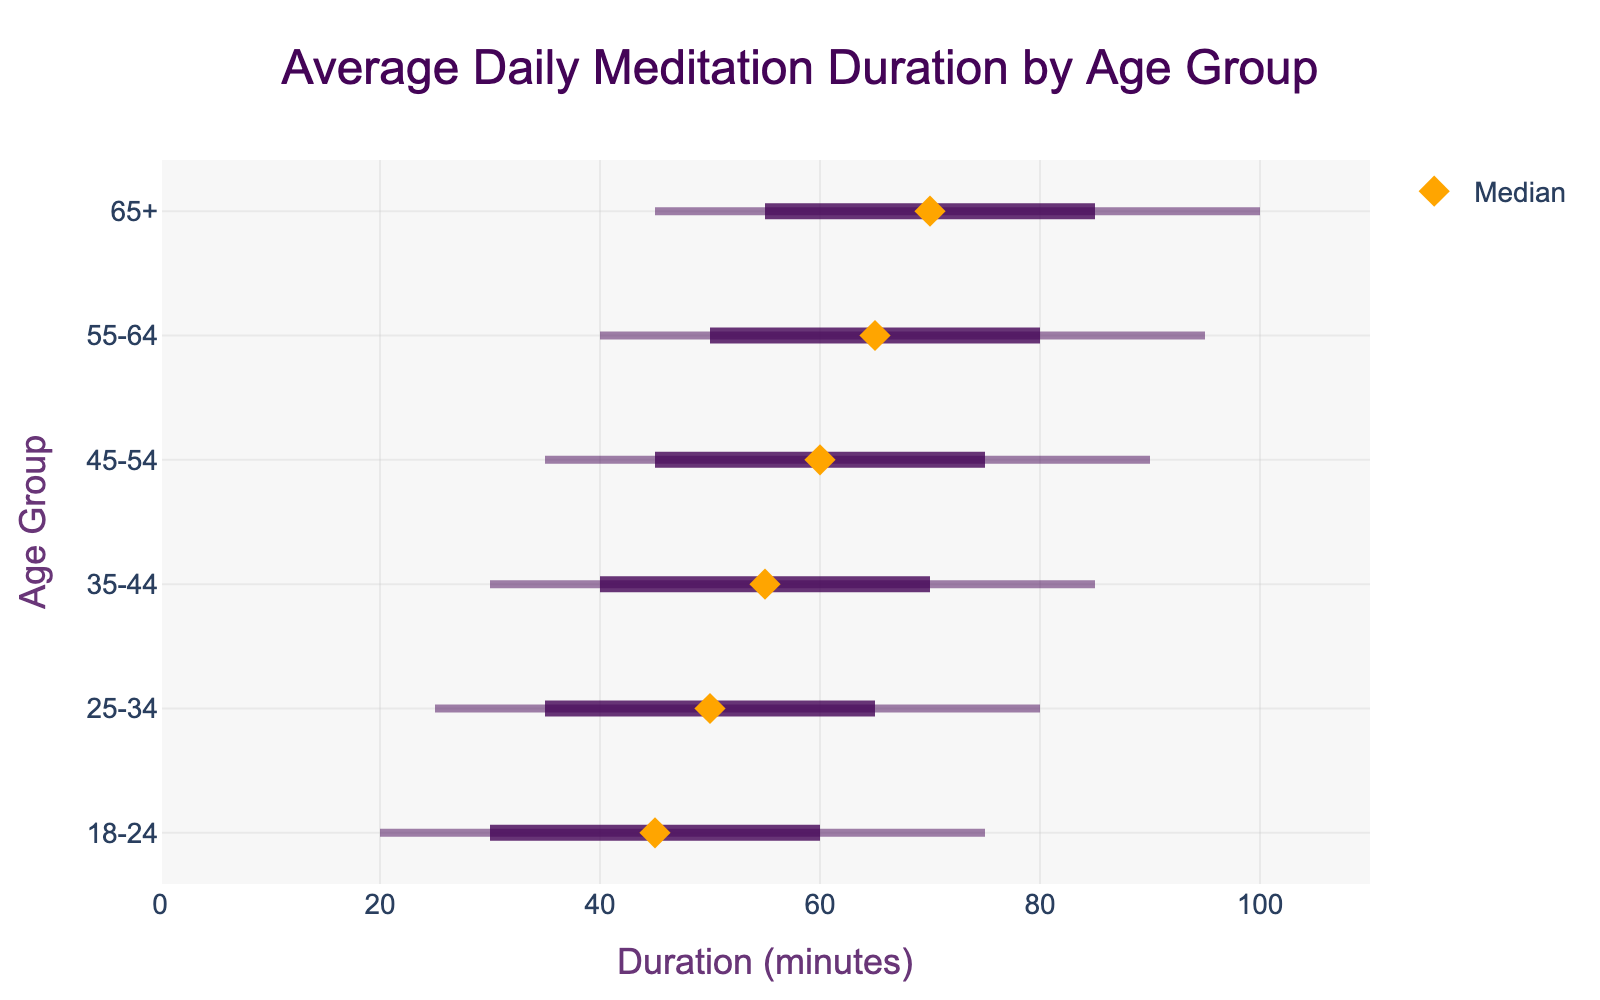What is the title of the figure? The title of the figure is typically placed at the top and summarizes what the figure is about. Here, it reads "Average Daily Meditation Duration by Age Group".
Answer: Average Daily Meditation Duration by Age Group What is the x-axis label? The x-axis label is located along the horizontal axis and indicates what data is represented on this axis. It reads "Duration (minutes)".
Answer: Duration (minutes) What is the median meditation duration for the age group 45-54? To find the median value for the age group 45-54, look at the point marked by a diamond along the dashed range for this age group. The diamond mark for 45-54 is at 60 minutes.
Answer: 60 Which age group has the highest 90th percentile meditation duration? To identify the highest 90th percentile, compare the end point of the dashed lines representing the 90th percentile for each age group. The age group 65+ has the highest end point at 100 minutes.
Answer: 65+ How does the median meditation duration change as the age group increases? Observe the position of the diamond markers from the youngest age group (18-24) to the oldest age group (65+). The median value increases as the age groups get older.
Answer: It increases Which age group has the smallest range between the 10th and 90th percentile durations? To determine the smallest range, look at the distance between the endpoints of the dashed lines for each age group. The range for 18-24 is 75 - 20 = 55 minutes, which is the smallest compared to the other age groups.
Answer: 18-24 What is the interquartile range (IQR) for the age group 35-44? The IQR is the range between the 25th percentile and the 75th percentile. For 35-44, subtract 40 (25th percentile) from 70 (75th percentile). IQR = 70 - 40 = 30 minutes.
Answer: 30 Compare the median values of the age groups 25-34 and 55-64. Which is greater? Compare the positions of the diamond markers along the dashed lines for both age groups. The median for 25-34 is at 50 minutes, and for 55-64, it is at 65 minutes, so 55-64 has a greater median value.
Answer: 55-64 Identify the 10th percentile meditation duration for the oldest age group (65+). The 10th percentile for the age group 65+ is marked at the start of the dashed line, which is 45 minutes.
Answer: 45 